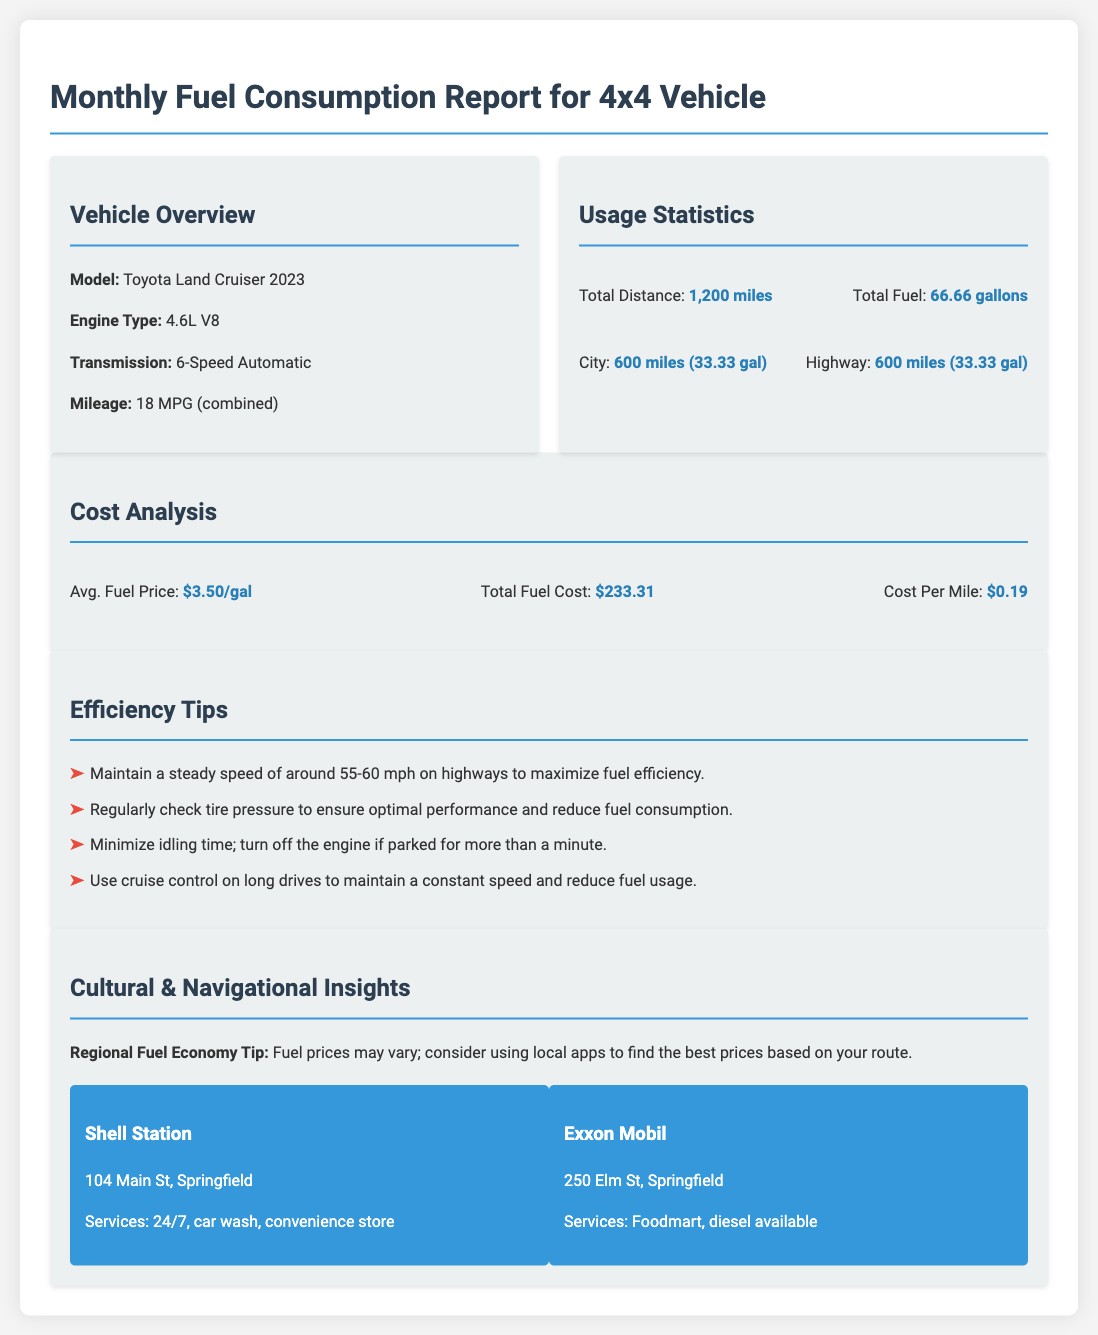What is the vehicle model? The vehicle model specified in the document is a Toyota Land Cruiser 2023.
Answer: Toyota Land Cruiser 2023 What is the total distance traveled? The total distance traveled is mentioned in the usage statistics section.
Answer: 1,200 miles How many gallons of fuel were used in the city? The document provides specific fuel usage for city travel, which is 33.33 gallons.
Answer: 33.33 gal What is the average fuel price? The average fuel price is provided in the cost analysis, which states it is $3.50 per gallon.
Answer: $3.50/gal What is the total fuel cost? The total fuel cost is calculated based on the average price and total fuel consumed, which is $233.31.
Answer: $233.31 What speed should be maintained for fuel efficiency? The tip for fuel efficiency regarding speed is specified in the document.
Answer: 55-60 mph How many miles were traveled on the highway? The document specifies the highway distance in the usage statistics section.
Answer: 600 miles What services are available at the Shell Station? The document lists services offered by the Shell Station located at 104 Main St, Springfield.
Answer: 24/7, car wash, convenience store What type of engine does the vehicle have? The document mentions the engine type used in the vehicle overview section.
Answer: 4.6L V8 